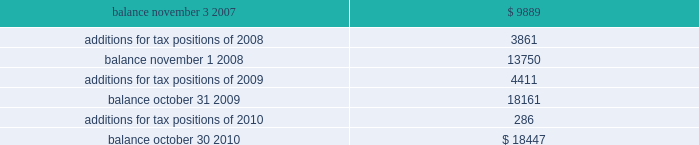Of global business , there are many transactions and calculations where the ultimate tax outcome is uncertain .
Some of these uncertainties arise as a consequence of cost reimbursement arrangements among related entities .
Although the company believes its estimates are reasonable , no assurance can be given that the final tax outcome of these matters will not be different than that which is reflected in the historical income tax provisions and accruals .
Such differences could have a material impact on the company 2019s income tax provision and operating results in the period in which such determination is made .
On november 4 , 2007 ( the first day of its 2008 fiscal year ) , the company adopted new accounting principles on accounting for uncertain tax positions .
These principles require companies to determine whether it is 201cmore likely than not 201d that a tax position will be sustained upon examination by the appropriate taxing authorities before any benefit can be recorded in the financial statements .
An uncertain income tax position will not be recognized if it has less than a 50% ( 50 % ) likelihood of being sustained .
There were no changes to the company 2019s liabilities for uncertain tax positions as a result of the adoption of these provisions .
As of october 30 , 2010 and october 31 , 2009 , the company had a liability of $ 18.4 million and $ 18.2 million , respectively , for gross unrealized tax benefits , all of which , if settled in the company 2019s favor , would lower the company 2019s effective tax rate in the period recorded .
In addition , as of october 30 , 2010 and october 31 , 2009 , the company had a liability of approximately $ 9.8 million and $ 8.0 million , respectively , for interest and penalties .
The total liability as of october 30 , 2010 and october 31 , 2009 of $ 28.3 million and $ 26.2 million , respectively , for uncertain tax positions is classified as non-current , and is included in other non-current liabilities , because the company believes that the ultimate payment or settlement of these liabilities will not occur within the next twelve months .
Prior to the adoption of these provisions , these amounts were included in current income tax payable .
The company includes interest and penalties related to unrecognized tax benefits within the provision for taxes in the condensed consolidated statements of income , and as a result , no change in classification was made upon adopting these provisions .
The condensed consolidated statements of income for fiscal years 2010 , 2009 and 2008 include $ 1.8 million , $ 1.7 million and $ 1.3 million , respectively , of interest and penalties related to these uncertain tax positions .
Due to the complexity associated with its tax uncertainties , the company cannot make a reasonably reliable estimate as to the period in which it expects to settle the liabilities associated with these uncertain tax positions .
The table summarizes the changes in the total amounts of uncertain tax positions for fiscal 2008 through fiscal 2010. .
Fiscal years 2004 and 2005 irs examination during the fourth quarter of fiscal 2007 , the irs completed its field examination of the company 2019s fiscal years 2004 and 2005 .
On january 2 , 2008 , the irs issued its report for fiscal 2004 and 2005 , which included proposed adjustments related to these two fiscal years .
The company has recorded taxes and penalties related to certain of these proposed adjustments .
There are four items with an additional potential total tax liability of $ 46 million .
The company has concluded , based on discussions with its tax advisors , that these four items are not likely to result in any additional tax liability .
Therefore , the company has not recorded any additional tax liability for these items and is appealing these proposed adjustments through the normal processes for the resolution of differences between the irs and taxpayers .
The company 2019s initial meetings with the appellate division of the irs were held during fiscal analog devices , inc .
Notes to consolidated financial statements 2014 ( continued ) .
What percentage did the balance increase from 2007 to 2010? 
Rationale: to find the percentage increase from 2007 to 2010 one must take the balance for 2010 and subtract that by the balance for 2007 . then take the answer and divide it by the balance for 2007 .
Computations: ((18447 - 9889) / 9889)
Answer: 0.86541. 